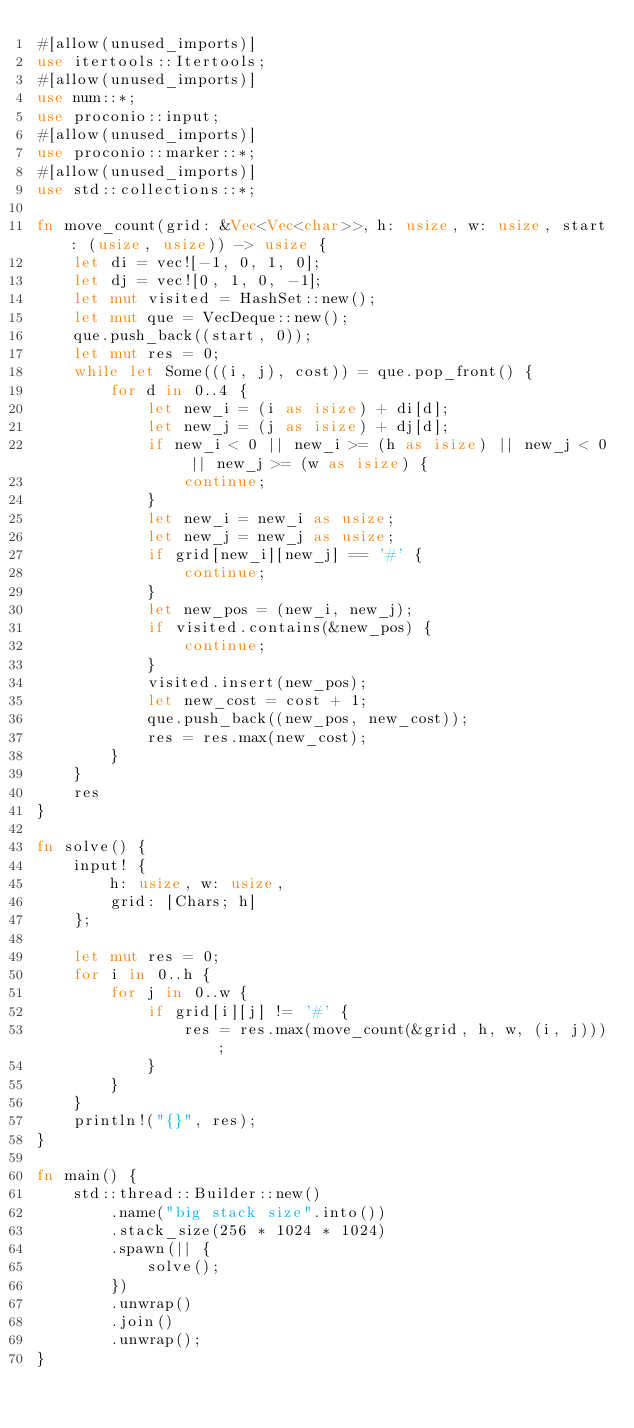Convert code to text. <code><loc_0><loc_0><loc_500><loc_500><_Rust_>#[allow(unused_imports)]
use itertools::Itertools;
#[allow(unused_imports)]
use num::*;
use proconio::input;
#[allow(unused_imports)]
use proconio::marker::*;
#[allow(unused_imports)]
use std::collections::*;

fn move_count(grid: &Vec<Vec<char>>, h: usize, w: usize, start: (usize, usize)) -> usize {
    let di = vec![-1, 0, 1, 0];
    let dj = vec![0, 1, 0, -1];
    let mut visited = HashSet::new();
    let mut que = VecDeque::new();
    que.push_back((start, 0));
    let mut res = 0;
    while let Some(((i, j), cost)) = que.pop_front() {
        for d in 0..4 {
            let new_i = (i as isize) + di[d];
            let new_j = (j as isize) + dj[d];
            if new_i < 0 || new_i >= (h as isize) || new_j < 0 || new_j >= (w as isize) {
                continue;
            }
            let new_i = new_i as usize;
            let new_j = new_j as usize;
            if grid[new_i][new_j] == '#' {
                continue;
            }
            let new_pos = (new_i, new_j);
            if visited.contains(&new_pos) {
                continue;
            }
            visited.insert(new_pos);
            let new_cost = cost + 1;
            que.push_back((new_pos, new_cost));
            res = res.max(new_cost);
        }
    }
    res
}

fn solve() {
    input! {
        h: usize, w: usize,
        grid: [Chars; h]
    };

    let mut res = 0;
    for i in 0..h {
        for j in 0..w {
            if grid[i][j] != '#' {
                res = res.max(move_count(&grid, h, w, (i, j)));
            }
        }
    }
    println!("{}", res);
}

fn main() {
    std::thread::Builder::new()
        .name("big stack size".into())
        .stack_size(256 * 1024 * 1024)
        .spawn(|| {
            solve();
        })
        .unwrap()
        .join()
        .unwrap();
}
</code> 